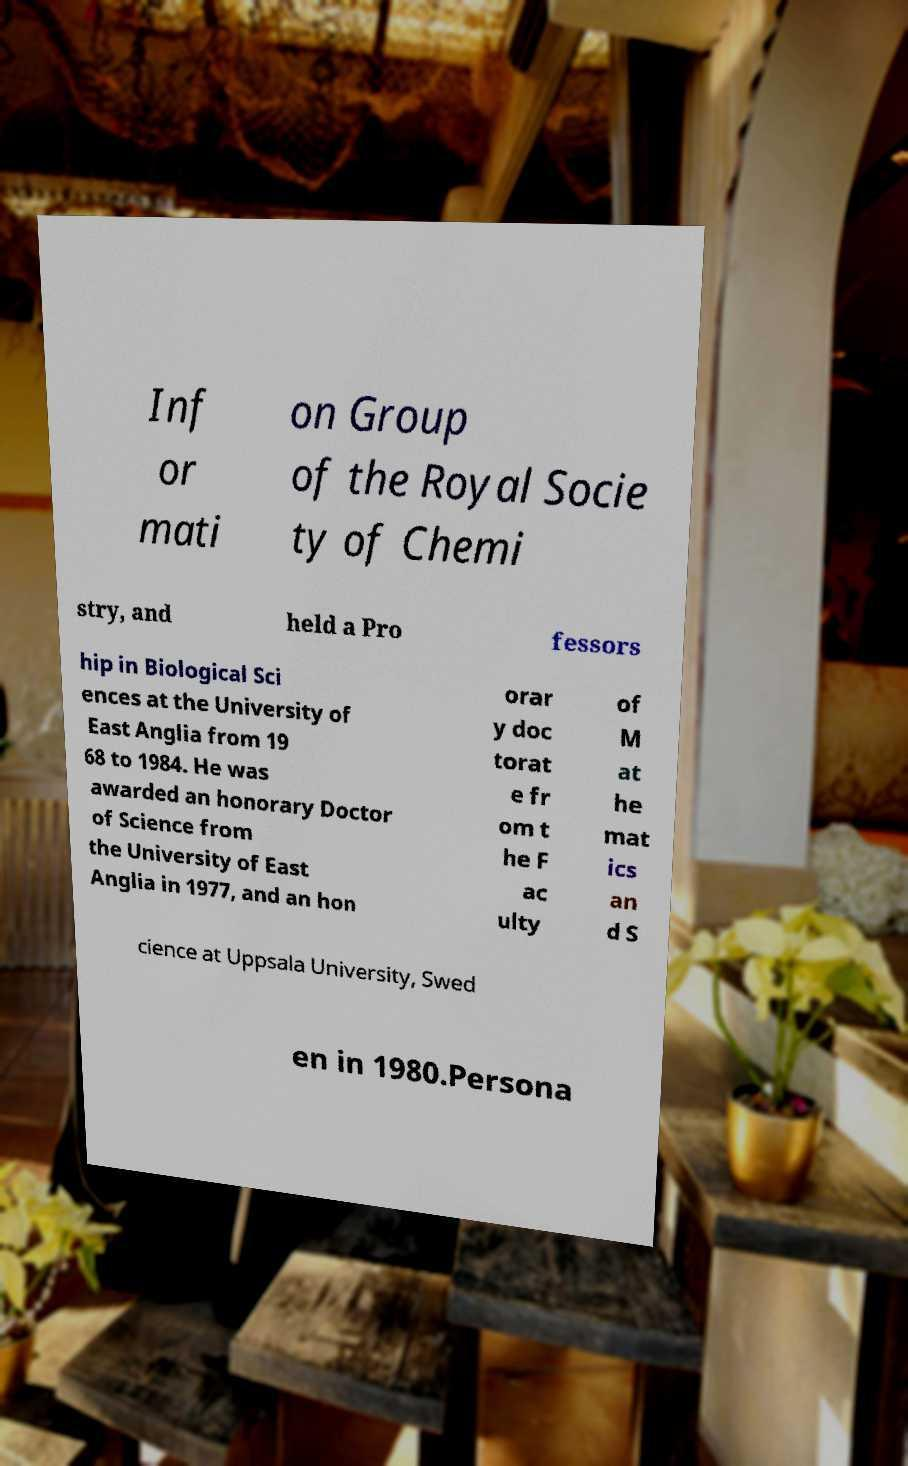Could you extract and type out the text from this image? Inf or mati on Group of the Royal Socie ty of Chemi stry, and held a Pro fessors hip in Biological Sci ences at the University of East Anglia from 19 68 to 1984. He was awarded an honorary Doctor of Science from the University of East Anglia in 1977, and an hon orar y doc torat e fr om t he F ac ulty of M at he mat ics an d S cience at Uppsala University, Swed en in 1980.Persona 